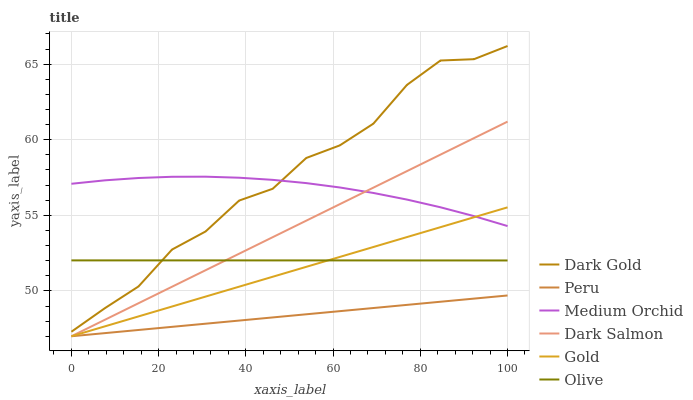Does Peru have the minimum area under the curve?
Answer yes or no. Yes. Does Dark Gold have the maximum area under the curve?
Answer yes or no. Yes. Does Medium Orchid have the minimum area under the curve?
Answer yes or no. No. Does Medium Orchid have the maximum area under the curve?
Answer yes or no. No. Is Gold the smoothest?
Answer yes or no. Yes. Is Dark Gold the roughest?
Answer yes or no. Yes. Is Medium Orchid the smoothest?
Answer yes or no. No. Is Medium Orchid the roughest?
Answer yes or no. No. Does Dark Gold have the lowest value?
Answer yes or no. No. Does Medium Orchid have the highest value?
Answer yes or no. No. Is Olive less than Medium Orchid?
Answer yes or no. Yes. Is Medium Orchid greater than Olive?
Answer yes or no. Yes. Does Olive intersect Medium Orchid?
Answer yes or no. No. 